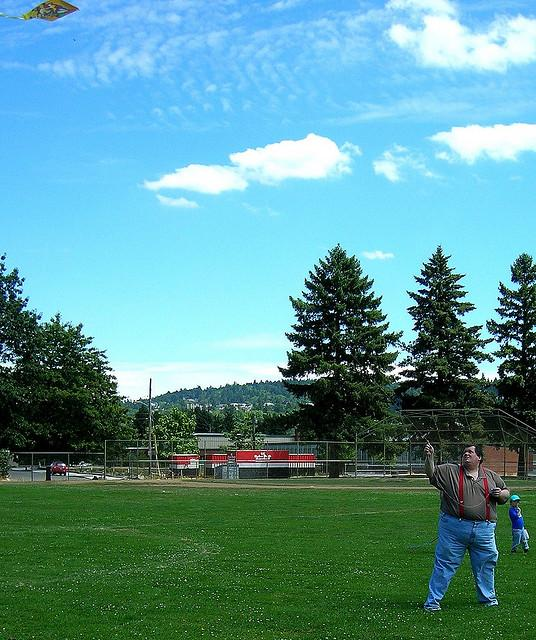The man in brown Controls what?

Choices:
A) grass
B) kite
C) flowers
D) dog kite 